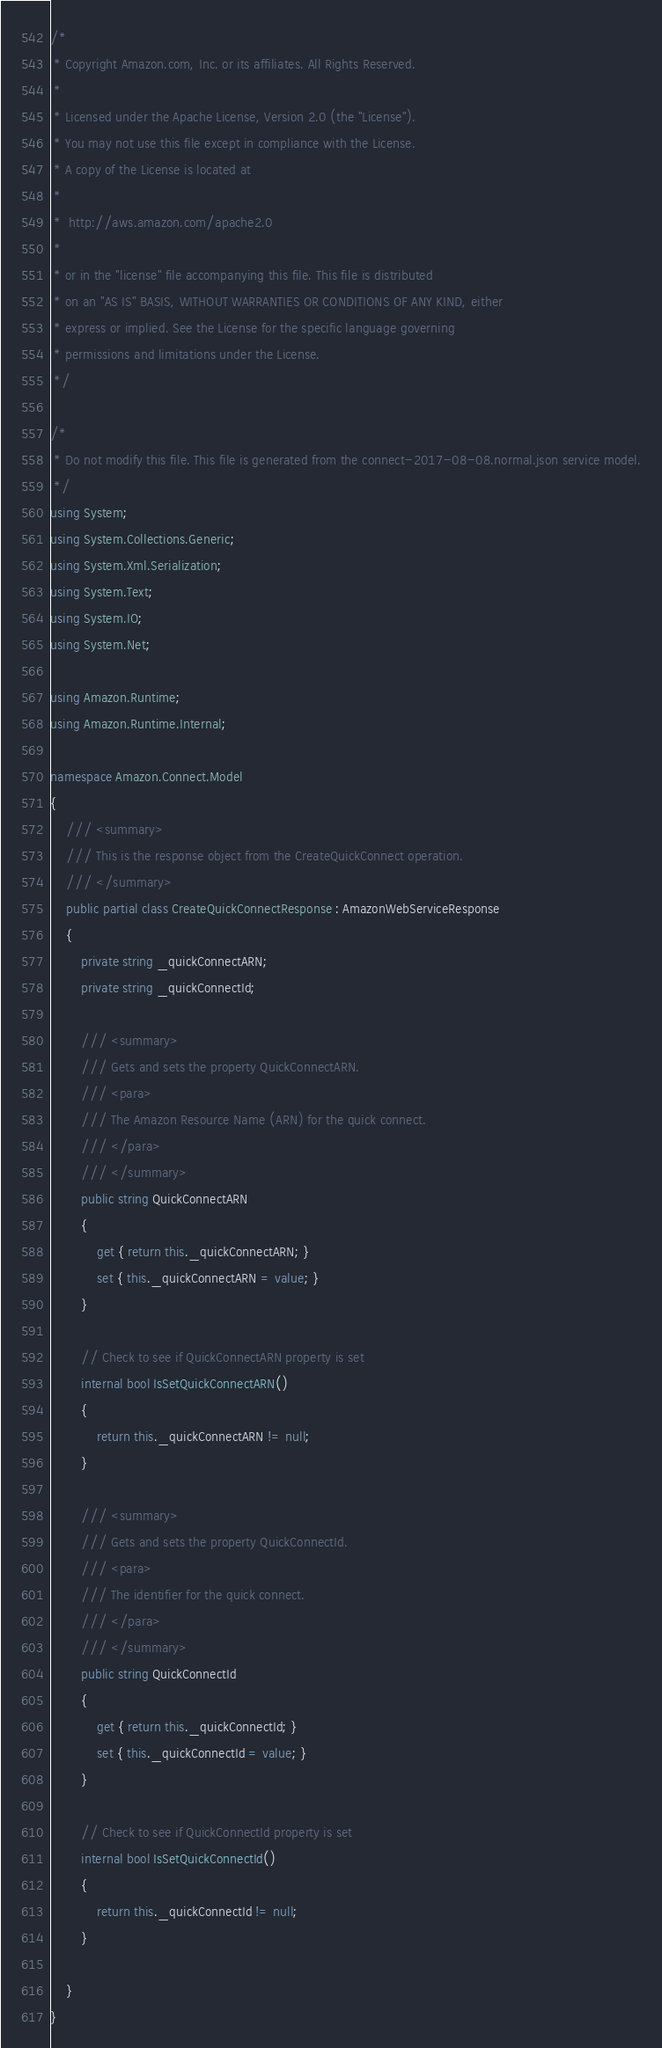Convert code to text. <code><loc_0><loc_0><loc_500><loc_500><_C#_>/*
 * Copyright Amazon.com, Inc. or its affiliates. All Rights Reserved.
 * 
 * Licensed under the Apache License, Version 2.0 (the "License").
 * You may not use this file except in compliance with the License.
 * A copy of the License is located at
 * 
 *  http://aws.amazon.com/apache2.0
 * 
 * or in the "license" file accompanying this file. This file is distributed
 * on an "AS IS" BASIS, WITHOUT WARRANTIES OR CONDITIONS OF ANY KIND, either
 * express or implied. See the License for the specific language governing
 * permissions and limitations under the License.
 */

/*
 * Do not modify this file. This file is generated from the connect-2017-08-08.normal.json service model.
 */
using System;
using System.Collections.Generic;
using System.Xml.Serialization;
using System.Text;
using System.IO;
using System.Net;

using Amazon.Runtime;
using Amazon.Runtime.Internal;

namespace Amazon.Connect.Model
{
    /// <summary>
    /// This is the response object from the CreateQuickConnect operation.
    /// </summary>
    public partial class CreateQuickConnectResponse : AmazonWebServiceResponse
    {
        private string _quickConnectARN;
        private string _quickConnectId;

        /// <summary>
        /// Gets and sets the property QuickConnectARN. 
        /// <para>
        /// The Amazon Resource Name (ARN) for the quick connect. 
        /// </para>
        /// </summary>
        public string QuickConnectARN
        {
            get { return this._quickConnectARN; }
            set { this._quickConnectARN = value; }
        }

        // Check to see if QuickConnectARN property is set
        internal bool IsSetQuickConnectARN()
        {
            return this._quickConnectARN != null;
        }

        /// <summary>
        /// Gets and sets the property QuickConnectId. 
        /// <para>
        /// The identifier for the quick connect. 
        /// </para>
        /// </summary>
        public string QuickConnectId
        {
            get { return this._quickConnectId; }
            set { this._quickConnectId = value; }
        }

        // Check to see if QuickConnectId property is set
        internal bool IsSetQuickConnectId()
        {
            return this._quickConnectId != null;
        }

    }
}</code> 